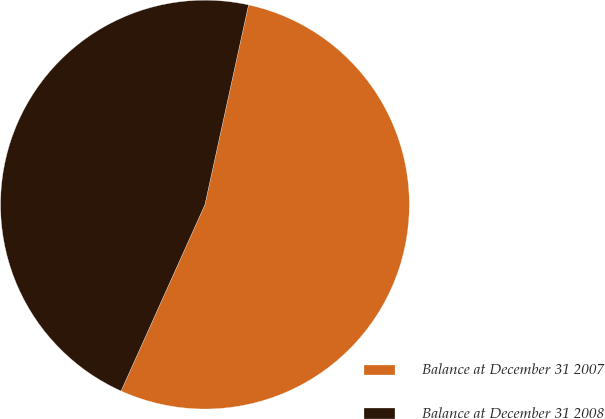<chart> <loc_0><loc_0><loc_500><loc_500><pie_chart><fcel>Balance at December 31 2007<fcel>Balance at December 31 2008<nl><fcel>53.31%<fcel>46.69%<nl></chart> 